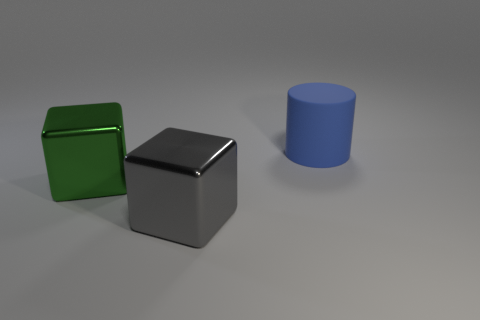Which object in the image looks closest to the source of light? The silver cube appears to be closest to the light source. This is deduced by the brightness and intensity of the highlights on its surface, as well as the sharpness of its shadow compared to the other objects. Could you describe the position of the light source based on the shadows? Based on the shadows cast by the cubes and the cylinder, the light source seems to be positioned above the objects, slightly off to the left side of the image. The shadows are angled to the bottom right, which supports this observation. 